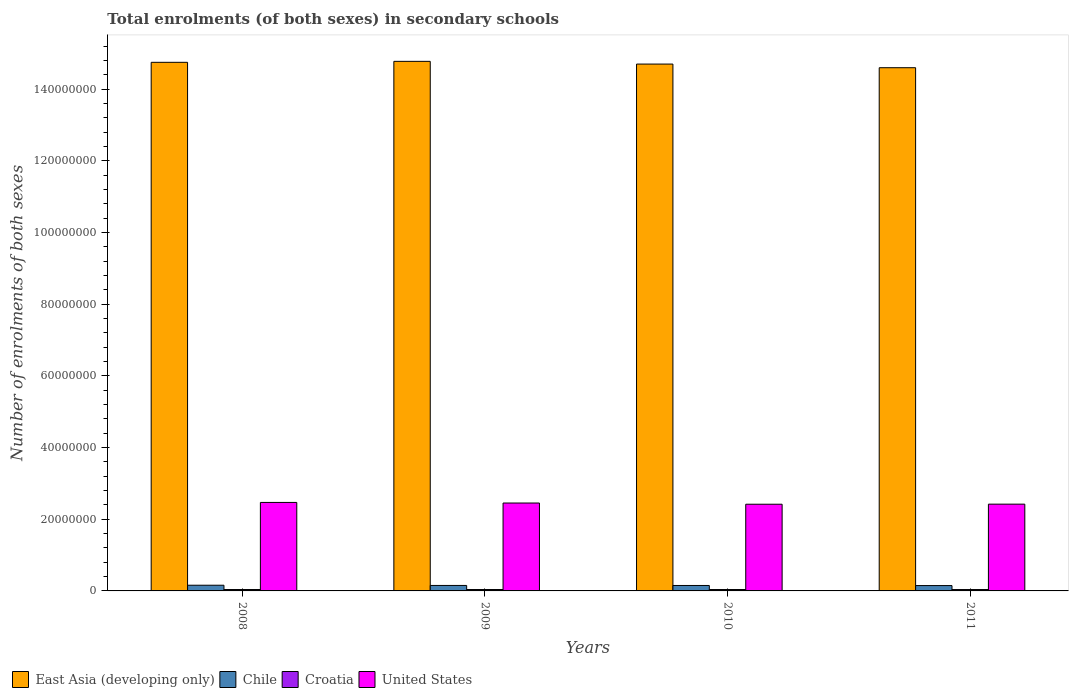How many groups of bars are there?
Make the answer very short. 4. Are the number of bars on each tick of the X-axis equal?
Offer a very short reply. Yes. How many bars are there on the 3rd tick from the right?
Provide a short and direct response. 4. What is the number of enrolments in secondary schools in Chile in 2010?
Your answer should be very brief. 1.52e+06. Across all years, what is the maximum number of enrolments in secondary schools in East Asia (developing only)?
Offer a terse response. 1.48e+08. Across all years, what is the minimum number of enrolments in secondary schools in East Asia (developing only)?
Make the answer very short. 1.46e+08. In which year was the number of enrolments in secondary schools in Chile minimum?
Ensure brevity in your answer.  2011. What is the total number of enrolments in secondary schools in Chile in the graph?
Offer a terse response. 6.13e+06. What is the difference between the number of enrolments in secondary schools in Chile in 2009 and that in 2011?
Your answer should be very brief. 3.52e+04. What is the difference between the number of enrolments in secondary schools in Croatia in 2008 and the number of enrolments in secondary schools in United States in 2009?
Offer a very short reply. -2.41e+07. What is the average number of enrolments in secondary schools in East Asia (developing only) per year?
Your response must be concise. 1.47e+08. In the year 2010, what is the difference between the number of enrolments in secondary schools in East Asia (developing only) and number of enrolments in secondary schools in Croatia?
Ensure brevity in your answer.  1.47e+08. In how many years, is the number of enrolments in secondary schools in East Asia (developing only) greater than 76000000?
Your answer should be compact. 4. What is the ratio of the number of enrolments in secondary schools in East Asia (developing only) in 2009 to that in 2011?
Your answer should be very brief. 1.01. Is the difference between the number of enrolments in secondary schools in East Asia (developing only) in 2010 and 2011 greater than the difference between the number of enrolments in secondary schools in Croatia in 2010 and 2011?
Offer a very short reply. Yes. What is the difference between the highest and the second highest number of enrolments in secondary schools in United States?
Give a very brief answer. 1.68e+05. What is the difference between the highest and the lowest number of enrolments in secondary schools in Chile?
Provide a succinct answer. 9.58e+04. In how many years, is the number of enrolments in secondary schools in Croatia greater than the average number of enrolments in secondary schools in Croatia taken over all years?
Make the answer very short. 2. Is the sum of the number of enrolments in secondary schools in East Asia (developing only) in 2009 and 2010 greater than the maximum number of enrolments in secondary schools in Croatia across all years?
Offer a terse response. Yes. What does the 1st bar from the right in 2008 represents?
Offer a terse response. United States. How many bars are there?
Provide a succinct answer. 16. What is the difference between two consecutive major ticks on the Y-axis?
Give a very brief answer. 2.00e+07. Does the graph contain any zero values?
Ensure brevity in your answer.  No. Does the graph contain grids?
Provide a short and direct response. No. How many legend labels are there?
Give a very brief answer. 4. What is the title of the graph?
Your answer should be very brief. Total enrolments (of both sexes) in secondary schools. What is the label or title of the X-axis?
Give a very brief answer. Years. What is the label or title of the Y-axis?
Your answer should be very brief. Number of enrolments of both sexes. What is the Number of enrolments of both sexes in East Asia (developing only) in 2008?
Your answer should be compact. 1.47e+08. What is the Number of enrolments of both sexes of Chile in 2008?
Provide a short and direct response. 1.59e+06. What is the Number of enrolments of both sexes in Croatia in 2008?
Your response must be concise. 3.92e+05. What is the Number of enrolments of both sexes of United States in 2008?
Give a very brief answer. 2.47e+07. What is the Number of enrolments of both sexes in East Asia (developing only) in 2009?
Your response must be concise. 1.48e+08. What is the Number of enrolments of both sexes in Chile in 2009?
Give a very brief answer. 1.53e+06. What is the Number of enrolments of both sexes in Croatia in 2009?
Make the answer very short. 3.91e+05. What is the Number of enrolments of both sexes in United States in 2009?
Make the answer very short. 2.45e+07. What is the Number of enrolments of both sexes in East Asia (developing only) in 2010?
Your response must be concise. 1.47e+08. What is the Number of enrolments of both sexes in Chile in 2010?
Offer a terse response. 1.52e+06. What is the Number of enrolments of both sexes in Croatia in 2010?
Your answer should be compact. 3.89e+05. What is the Number of enrolments of both sexes in United States in 2010?
Provide a short and direct response. 2.42e+07. What is the Number of enrolments of both sexes of East Asia (developing only) in 2011?
Your answer should be compact. 1.46e+08. What is the Number of enrolments of both sexes of Chile in 2011?
Your response must be concise. 1.49e+06. What is the Number of enrolments of both sexes in Croatia in 2011?
Give a very brief answer. 3.84e+05. What is the Number of enrolments of both sexes of United States in 2011?
Give a very brief answer. 2.42e+07. Across all years, what is the maximum Number of enrolments of both sexes of East Asia (developing only)?
Provide a short and direct response. 1.48e+08. Across all years, what is the maximum Number of enrolments of both sexes in Chile?
Offer a very short reply. 1.59e+06. Across all years, what is the maximum Number of enrolments of both sexes in Croatia?
Offer a very short reply. 3.92e+05. Across all years, what is the maximum Number of enrolments of both sexes in United States?
Your answer should be very brief. 2.47e+07. Across all years, what is the minimum Number of enrolments of both sexes of East Asia (developing only)?
Keep it short and to the point. 1.46e+08. Across all years, what is the minimum Number of enrolments of both sexes of Chile?
Provide a short and direct response. 1.49e+06. Across all years, what is the minimum Number of enrolments of both sexes in Croatia?
Provide a succinct answer. 3.84e+05. Across all years, what is the minimum Number of enrolments of both sexes of United States?
Ensure brevity in your answer.  2.42e+07. What is the total Number of enrolments of both sexes in East Asia (developing only) in the graph?
Offer a terse response. 5.88e+08. What is the total Number of enrolments of both sexes of Chile in the graph?
Your answer should be very brief. 6.13e+06. What is the total Number of enrolments of both sexes in Croatia in the graph?
Your answer should be very brief. 1.56e+06. What is the total Number of enrolments of both sexes of United States in the graph?
Make the answer very short. 9.76e+07. What is the difference between the Number of enrolments of both sexes of East Asia (developing only) in 2008 and that in 2009?
Ensure brevity in your answer.  -2.70e+05. What is the difference between the Number of enrolments of both sexes of Chile in 2008 and that in 2009?
Make the answer very short. 6.06e+04. What is the difference between the Number of enrolments of both sexes of Croatia in 2008 and that in 2009?
Your answer should be very brief. 200. What is the difference between the Number of enrolments of both sexes of United States in 2008 and that in 2009?
Provide a short and direct response. 1.68e+05. What is the difference between the Number of enrolments of both sexes in East Asia (developing only) in 2008 and that in 2010?
Provide a short and direct response. 4.87e+05. What is the difference between the Number of enrolments of both sexes of Chile in 2008 and that in 2010?
Keep it short and to the point. 7.06e+04. What is the difference between the Number of enrolments of both sexes in Croatia in 2008 and that in 2010?
Provide a succinct answer. 3122. What is the difference between the Number of enrolments of both sexes in United States in 2008 and that in 2010?
Offer a terse response. 5.00e+05. What is the difference between the Number of enrolments of both sexes of East Asia (developing only) in 2008 and that in 2011?
Your answer should be very brief. 1.50e+06. What is the difference between the Number of enrolments of both sexes of Chile in 2008 and that in 2011?
Provide a short and direct response. 9.58e+04. What is the difference between the Number of enrolments of both sexes in Croatia in 2008 and that in 2011?
Keep it short and to the point. 7629. What is the difference between the Number of enrolments of both sexes of United States in 2008 and that in 2011?
Keep it short and to the point. 4.79e+05. What is the difference between the Number of enrolments of both sexes in East Asia (developing only) in 2009 and that in 2010?
Give a very brief answer. 7.58e+05. What is the difference between the Number of enrolments of both sexes of Chile in 2009 and that in 2010?
Your answer should be very brief. 9976. What is the difference between the Number of enrolments of both sexes of Croatia in 2009 and that in 2010?
Your answer should be compact. 2922. What is the difference between the Number of enrolments of both sexes in United States in 2009 and that in 2010?
Your answer should be very brief. 3.32e+05. What is the difference between the Number of enrolments of both sexes in East Asia (developing only) in 2009 and that in 2011?
Your answer should be very brief. 1.77e+06. What is the difference between the Number of enrolments of both sexes in Chile in 2009 and that in 2011?
Your answer should be compact. 3.52e+04. What is the difference between the Number of enrolments of both sexes in Croatia in 2009 and that in 2011?
Your answer should be compact. 7429. What is the difference between the Number of enrolments of both sexes in United States in 2009 and that in 2011?
Ensure brevity in your answer.  3.10e+05. What is the difference between the Number of enrolments of both sexes of East Asia (developing only) in 2010 and that in 2011?
Ensure brevity in your answer.  1.01e+06. What is the difference between the Number of enrolments of both sexes of Chile in 2010 and that in 2011?
Offer a terse response. 2.52e+04. What is the difference between the Number of enrolments of both sexes of Croatia in 2010 and that in 2011?
Offer a terse response. 4507. What is the difference between the Number of enrolments of both sexes in United States in 2010 and that in 2011?
Offer a very short reply. -2.15e+04. What is the difference between the Number of enrolments of both sexes of East Asia (developing only) in 2008 and the Number of enrolments of both sexes of Chile in 2009?
Your answer should be compact. 1.46e+08. What is the difference between the Number of enrolments of both sexes in East Asia (developing only) in 2008 and the Number of enrolments of both sexes in Croatia in 2009?
Give a very brief answer. 1.47e+08. What is the difference between the Number of enrolments of both sexes in East Asia (developing only) in 2008 and the Number of enrolments of both sexes in United States in 2009?
Give a very brief answer. 1.23e+08. What is the difference between the Number of enrolments of both sexes of Chile in 2008 and the Number of enrolments of both sexes of Croatia in 2009?
Provide a short and direct response. 1.20e+06. What is the difference between the Number of enrolments of both sexes of Chile in 2008 and the Number of enrolments of both sexes of United States in 2009?
Provide a short and direct response. -2.29e+07. What is the difference between the Number of enrolments of both sexes in Croatia in 2008 and the Number of enrolments of both sexes in United States in 2009?
Provide a succinct answer. -2.41e+07. What is the difference between the Number of enrolments of both sexes in East Asia (developing only) in 2008 and the Number of enrolments of both sexes in Chile in 2010?
Keep it short and to the point. 1.46e+08. What is the difference between the Number of enrolments of both sexes of East Asia (developing only) in 2008 and the Number of enrolments of both sexes of Croatia in 2010?
Make the answer very short. 1.47e+08. What is the difference between the Number of enrolments of both sexes of East Asia (developing only) in 2008 and the Number of enrolments of both sexes of United States in 2010?
Give a very brief answer. 1.23e+08. What is the difference between the Number of enrolments of both sexes of Chile in 2008 and the Number of enrolments of both sexes of Croatia in 2010?
Make the answer very short. 1.20e+06. What is the difference between the Number of enrolments of both sexes in Chile in 2008 and the Number of enrolments of both sexes in United States in 2010?
Provide a short and direct response. -2.26e+07. What is the difference between the Number of enrolments of both sexes of Croatia in 2008 and the Number of enrolments of both sexes of United States in 2010?
Provide a succinct answer. -2.38e+07. What is the difference between the Number of enrolments of both sexes of East Asia (developing only) in 2008 and the Number of enrolments of both sexes of Chile in 2011?
Provide a succinct answer. 1.46e+08. What is the difference between the Number of enrolments of both sexes of East Asia (developing only) in 2008 and the Number of enrolments of both sexes of Croatia in 2011?
Provide a short and direct response. 1.47e+08. What is the difference between the Number of enrolments of both sexes of East Asia (developing only) in 2008 and the Number of enrolments of both sexes of United States in 2011?
Offer a terse response. 1.23e+08. What is the difference between the Number of enrolments of both sexes of Chile in 2008 and the Number of enrolments of both sexes of Croatia in 2011?
Provide a short and direct response. 1.20e+06. What is the difference between the Number of enrolments of both sexes in Chile in 2008 and the Number of enrolments of both sexes in United States in 2011?
Offer a very short reply. -2.26e+07. What is the difference between the Number of enrolments of both sexes of Croatia in 2008 and the Number of enrolments of both sexes of United States in 2011?
Your response must be concise. -2.38e+07. What is the difference between the Number of enrolments of both sexes of East Asia (developing only) in 2009 and the Number of enrolments of both sexes of Chile in 2010?
Provide a short and direct response. 1.46e+08. What is the difference between the Number of enrolments of both sexes of East Asia (developing only) in 2009 and the Number of enrolments of both sexes of Croatia in 2010?
Offer a terse response. 1.47e+08. What is the difference between the Number of enrolments of both sexes of East Asia (developing only) in 2009 and the Number of enrolments of both sexes of United States in 2010?
Offer a terse response. 1.24e+08. What is the difference between the Number of enrolments of both sexes in Chile in 2009 and the Number of enrolments of both sexes in Croatia in 2010?
Give a very brief answer. 1.14e+06. What is the difference between the Number of enrolments of both sexes in Chile in 2009 and the Number of enrolments of both sexes in United States in 2010?
Offer a very short reply. -2.27e+07. What is the difference between the Number of enrolments of both sexes in Croatia in 2009 and the Number of enrolments of both sexes in United States in 2010?
Your response must be concise. -2.38e+07. What is the difference between the Number of enrolments of both sexes of East Asia (developing only) in 2009 and the Number of enrolments of both sexes of Chile in 2011?
Offer a terse response. 1.46e+08. What is the difference between the Number of enrolments of both sexes in East Asia (developing only) in 2009 and the Number of enrolments of both sexes in Croatia in 2011?
Provide a succinct answer. 1.47e+08. What is the difference between the Number of enrolments of both sexes in East Asia (developing only) in 2009 and the Number of enrolments of both sexes in United States in 2011?
Offer a very short reply. 1.24e+08. What is the difference between the Number of enrolments of both sexes of Chile in 2009 and the Number of enrolments of both sexes of Croatia in 2011?
Keep it short and to the point. 1.14e+06. What is the difference between the Number of enrolments of both sexes in Chile in 2009 and the Number of enrolments of both sexes in United States in 2011?
Provide a succinct answer. -2.27e+07. What is the difference between the Number of enrolments of both sexes in Croatia in 2009 and the Number of enrolments of both sexes in United States in 2011?
Keep it short and to the point. -2.38e+07. What is the difference between the Number of enrolments of both sexes of East Asia (developing only) in 2010 and the Number of enrolments of both sexes of Chile in 2011?
Provide a succinct answer. 1.46e+08. What is the difference between the Number of enrolments of both sexes in East Asia (developing only) in 2010 and the Number of enrolments of both sexes in Croatia in 2011?
Offer a very short reply. 1.47e+08. What is the difference between the Number of enrolments of both sexes in East Asia (developing only) in 2010 and the Number of enrolments of both sexes in United States in 2011?
Your response must be concise. 1.23e+08. What is the difference between the Number of enrolments of both sexes in Chile in 2010 and the Number of enrolments of both sexes in Croatia in 2011?
Offer a very short reply. 1.13e+06. What is the difference between the Number of enrolments of both sexes of Chile in 2010 and the Number of enrolments of both sexes of United States in 2011?
Offer a terse response. -2.27e+07. What is the difference between the Number of enrolments of both sexes in Croatia in 2010 and the Number of enrolments of both sexes in United States in 2011?
Your answer should be compact. -2.38e+07. What is the average Number of enrolments of both sexes in East Asia (developing only) per year?
Your answer should be compact. 1.47e+08. What is the average Number of enrolments of both sexes in Chile per year?
Ensure brevity in your answer.  1.53e+06. What is the average Number of enrolments of both sexes in Croatia per year?
Your answer should be compact. 3.89e+05. What is the average Number of enrolments of both sexes in United States per year?
Provide a short and direct response. 2.44e+07. In the year 2008, what is the difference between the Number of enrolments of both sexes of East Asia (developing only) and Number of enrolments of both sexes of Chile?
Your answer should be compact. 1.46e+08. In the year 2008, what is the difference between the Number of enrolments of both sexes of East Asia (developing only) and Number of enrolments of both sexes of Croatia?
Your response must be concise. 1.47e+08. In the year 2008, what is the difference between the Number of enrolments of both sexes of East Asia (developing only) and Number of enrolments of both sexes of United States?
Keep it short and to the point. 1.23e+08. In the year 2008, what is the difference between the Number of enrolments of both sexes in Chile and Number of enrolments of both sexes in Croatia?
Give a very brief answer. 1.20e+06. In the year 2008, what is the difference between the Number of enrolments of both sexes in Chile and Number of enrolments of both sexes in United States?
Offer a very short reply. -2.31e+07. In the year 2008, what is the difference between the Number of enrolments of both sexes in Croatia and Number of enrolments of both sexes in United States?
Make the answer very short. -2.43e+07. In the year 2009, what is the difference between the Number of enrolments of both sexes of East Asia (developing only) and Number of enrolments of both sexes of Chile?
Your response must be concise. 1.46e+08. In the year 2009, what is the difference between the Number of enrolments of both sexes of East Asia (developing only) and Number of enrolments of both sexes of Croatia?
Ensure brevity in your answer.  1.47e+08. In the year 2009, what is the difference between the Number of enrolments of both sexes in East Asia (developing only) and Number of enrolments of both sexes in United States?
Provide a short and direct response. 1.23e+08. In the year 2009, what is the difference between the Number of enrolments of both sexes in Chile and Number of enrolments of both sexes in Croatia?
Offer a terse response. 1.14e+06. In the year 2009, what is the difference between the Number of enrolments of both sexes of Chile and Number of enrolments of both sexes of United States?
Provide a short and direct response. -2.30e+07. In the year 2009, what is the difference between the Number of enrolments of both sexes of Croatia and Number of enrolments of both sexes of United States?
Your response must be concise. -2.41e+07. In the year 2010, what is the difference between the Number of enrolments of both sexes of East Asia (developing only) and Number of enrolments of both sexes of Chile?
Make the answer very short. 1.45e+08. In the year 2010, what is the difference between the Number of enrolments of both sexes of East Asia (developing only) and Number of enrolments of both sexes of Croatia?
Your answer should be very brief. 1.47e+08. In the year 2010, what is the difference between the Number of enrolments of both sexes of East Asia (developing only) and Number of enrolments of both sexes of United States?
Provide a succinct answer. 1.23e+08. In the year 2010, what is the difference between the Number of enrolments of both sexes in Chile and Number of enrolments of both sexes in Croatia?
Ensure brevity in your answer.  1.13e+06. In the year 2010, what is the difference between the Number of enrolments of both sexes in Chile and Number of enrolments of both sexes in United States?
Your response must be concise. -2.27e+07. In the year 2010, what is the difference between the Number of enrolments of both sexes in Croatia and Number of enrolments of both sexes in United States?
Your answer should be very brief. -2.38e+07. In the year 2011, what is the difference between the Number of enrolments of both sexes of East Asia (developing only) and Number of enrolments of both sexes of Chile?
Your answer should be very brief. 1.45e+08. In the year 2011, what is the difference between the Number of enrolments of both sexes in East Asia (developing only) and Number of enrolments of both sexes in Croatia?
Keep it short and to the point. 1.46e+08. In the year 2011, what is the difference between the Number of enrolments of both sexes of East Asia (developing only) and Number of enrolments of both sexes of United States?
Offer a very short reply. 1.22e+08. In the year 2011, what is the difference between the Number of enrolments of both sexes in Chile and Number of enrolments of both sexes in Croatia?
Offer a very short reply. 1.11e+06. In the year 2011, what is the difference between the Number of enrolments of both sexes in Chile and Number of enrolments of both sexes in United States?
Give a very brief answer. -2.27e+07. In the year 2011, what is the difference between the Number of enrolments of both sexes in Croatia and Number of enrolments of both sexes in United States?
Your answer should be very brief. -2.38e+07. What is the ratio of the Number of enrolments of both sexes in Chile in 2008 to that in 2009?
Ensure brevity in your answer.  1.04. What is the ratio of the Number of enrolments of both sexes of Croatia in 2008 to that in 2009?
Your response must be concise. 1. What is the ratio of the Number of enrolments of both sexes of East Asia (developing only) in 2008 to that in 2010?
Provide a short and direct response. 1. What is the ratio of the Number of enrolments of both sexes of Chile in 2008 to that in 2010?
Offer a terse response. 1.05. What is the ratio of the Number of enrolments of both sexes in United States in 2008 to that in 2010?
Your answer should be very brief. 1.02. What is the ratio of the Number of enrolments of both sexes in East Asia (developing only) in 2008 to that in 2011?
Make the answer very short. 1.01. What is the ratio of the Number of enrolments of both sexes of Chile in 2008 to that in 2011?
Provide a short and direct response. 1.06. What is the ratio of the Number of enrolments of both sexes in Croatia in 2008 to that in 2011?
Offer a very short reply. 1.02. What is the ratio of the Number of enrolments of both sexes of United States in 2008 to that in 2011?
Your answer should be very brief. 1.02. What is the ratio of the Number of enrolments of both sexes of Chile in 2009 to that in 2010?
Your answer should be very brief. 1.01. What is the ratio of the Number of enrolments of both sexes in Croatia in 2009 to that in 2010?
Make the answer very short. 1.01. What is the ratio of the Number of enrolments of both sexes of United States in 2009 to that in 2010?
Provide a short and direct response. 1.01. What is the ratio of the Number of enrolments of both sexes of East Asia (developing only) in 2009 to that in 2011?
Your answer should be compact. 1.01. What is the ratio of the Number of enrolments of both sexes in Chile in 2009 to that in 2011?
Your response must be concise. 1.02. What is the ratio of the Number of enrolments of both sexes of Croatia in 2009 to that in 2011?
Ensure brevity in your answer.  1.02. What is the ratio of the Number of enrolments of both sexes of United States in 2009 to that in 2011?
Make the answer very short. 1.01. What is the ratio of the Number of enrolments of both sexes in East Asia (developing only) in 2010 to that in 2011?
Provide a short and direct response. 1.01. What is the ratio of the Number of enrolments of both sexes in Chile in 2010 to that in 2011?
Offer a terse response. 1.02. What is the ratio of the Number of enrolments of both sexes in Croatia in 2010 to that in 2011?
Your answer should be compact. 1.01. What is the difference between the highest and the second highest Number of enrolments of both sexes in East Asia (developing only)?
Make the answer very short. 2.70e+05. What is the difference between the highest and the second highest Number of enrolments of both sexes in Chile?
Give a very brief answer. 6.06e+04. What is the difference between the highest and the second highest Number of enrolments of both sexes in United States?
Offer a terse response. 1.68e+05. What is the difference between the highest and the lowest Number of enrolments of both sexes of East Asia (developing only)?
Give a very brief answer. 1.77e+06. What is the difference between the highest and the lowest Number of enrolments of both sexes of Chile?
Offer a very short reply. 9.58e+04. What is the difference between the highest and the lowest Number of enrolments of both sexes of Croatia?
Keep it short and to the point. 7629. What is the difference between the highest and the lowest Number of enrolments of both sexes of United States?
Make the answer very short. 5.00e+05. 